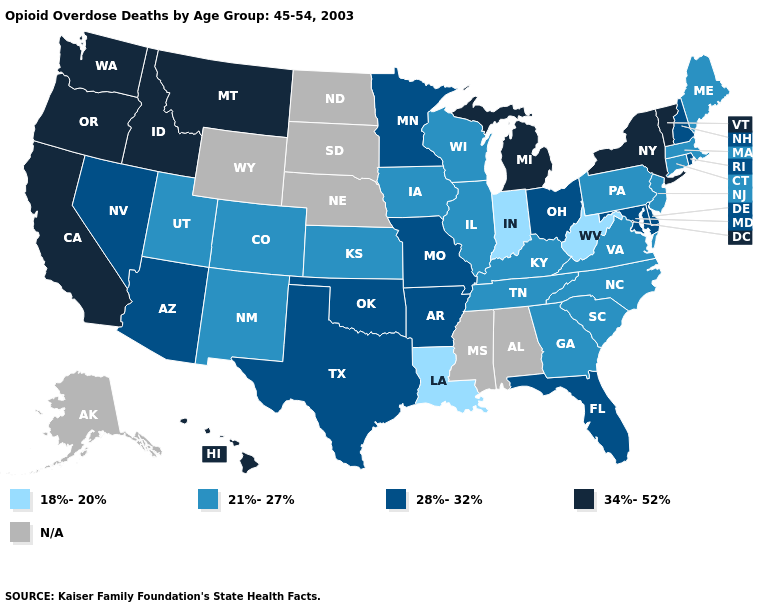Does New Mexico have the highest value in the USA?
Give a very brief answer. No. Does Massachusetts have the lowest value in the Northeast?
Be succinct. Yes. Among the states that border Nevada , does Oregon have the lowest value?
Write a very short answer. No. What is the lowest value in the USA?
Concise answer only. 18%-20%. Name the states that have a value in the range N/A?
Be succinct. Alabama, Alaska, Mississippi, Nebraska, North Dakota, South Dakota, Wyoming. Which states have the highest value in the USA?
Concise answer only. California, Hawaii, Idaho, Michigan, Montana, New York, Oregon, Vermont, Washington. What is the highest value in the USA?
Give a very brief answer. 34%-52%. How many symbols are there in the legend?
Answer briefly. 5. What is the value of Montana?
Keep it brief. 34%-52%. What is the lowest value in states that border Minnesota?
Keep it brief. 21%-27%. What is the lowest value in the MidWest?
Write a very short answer. 18%-20%. Name the states that have a value in the range 34%-52%?
Give a very brief answer. California, Hawaii, Idaho, Michigan, Montana, New York, Oregon, Vermont, Washington. Which states have the highest value in the USA?
Short answer required. California, Hawaii, Idaho, Michigan, Montana, New York, Oregon, Vermont, Washington. Name the states that have a value in the range 28%-32%?
Write a very short answer. Arizona, Arkansas, Delaware, Florida, Maryland, Minnesota, Missouri, Nevada, New Hampshire, Ohio, Oklahoma, Rhode Island, Texas. 